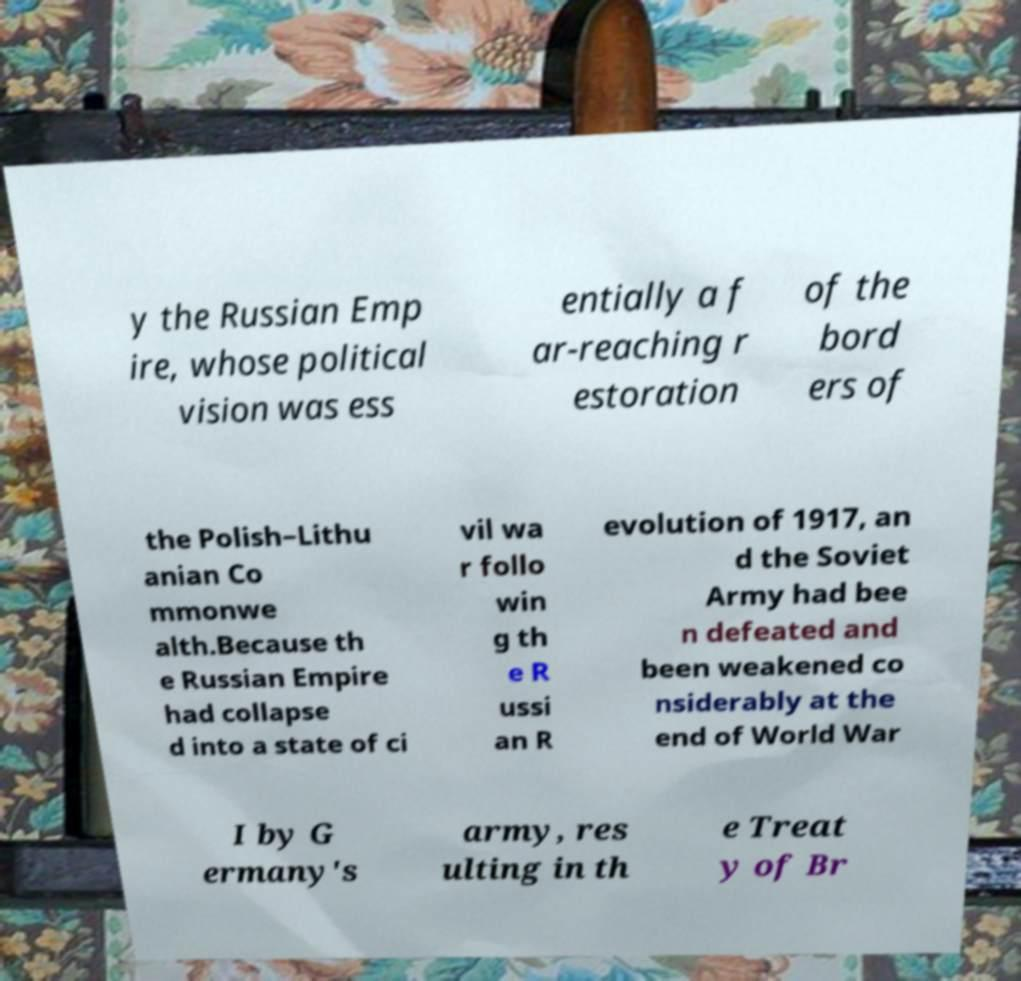Please read and relay the text visible in this image. What does it say? y the Russian Emp ire, whose political vision was ess entially a f ar-reaching r estoration of the bord ers of the Polish–Lithu anian Co mmonwe alth.Because th e Russian Empire had collapse d into a state of ci vil wa r follo win g th e R ussi an R evolution of 1917, an d the Soviet Army had bee n defeated and been weakened co nsiderably at the end of World War I by G ermany's army, res ulting in th e Treat y of Br 